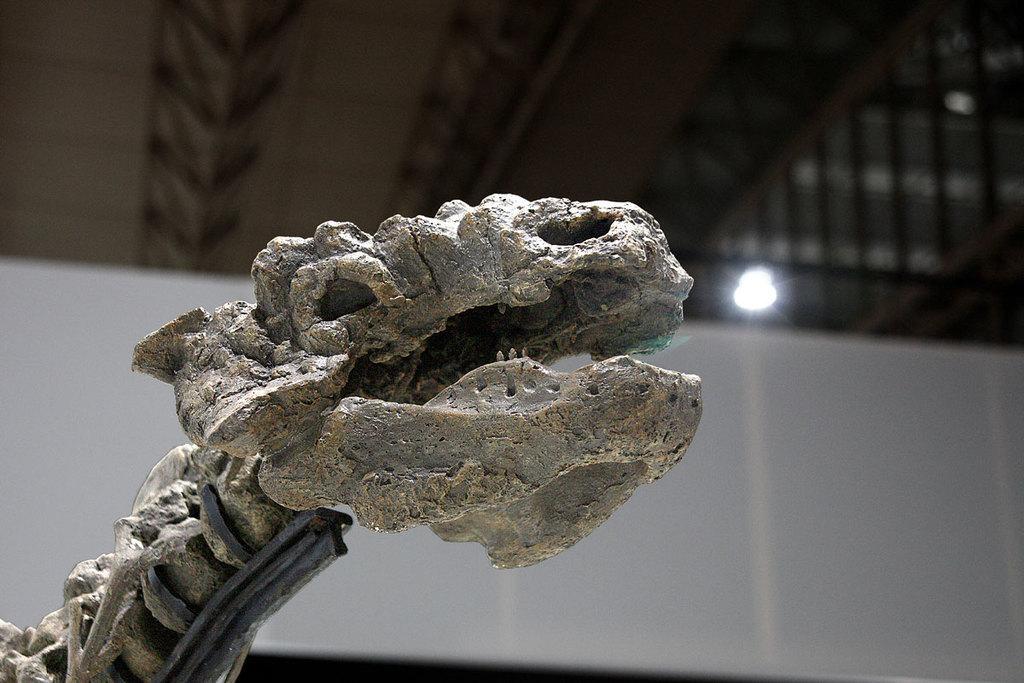Can you describe this image briefly? In this image I can see the skeleton of the dinosaur. In the background I can see the light and I can see the white color cloth. 